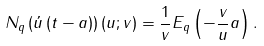Convert formula to latex. <formula><loc_0><loc_0><loc_500><loc_500>N _ { q } \left ( \acute { u } \left ( t - a \right ) \right ) \left ( u ; v \right ) = \frac { 1 } { v } E _ { q } \left ( - \frac { v } { u } a \right ) .</formula> 